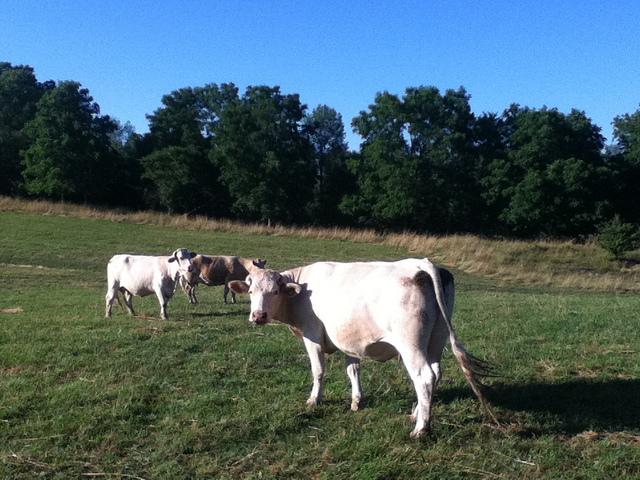How big is the cow?
Quick response, please. Very big. What is there for the cows to eat?
Concise answer only. Grass. Is the sky clear?
Give a very brief answer. Yes. How many cows can be seen?
Be succinct. 3. How many cows are looking at the camera?
Be succinct. 2. Is there snow covering the ground?
Answer briefly. No. How is the weather?
Concise answer only. Sunny. Are these cows Dairy cows?
Give a very brief answer. Yes. What colors are the cows?
Give a very brief answer. White. 